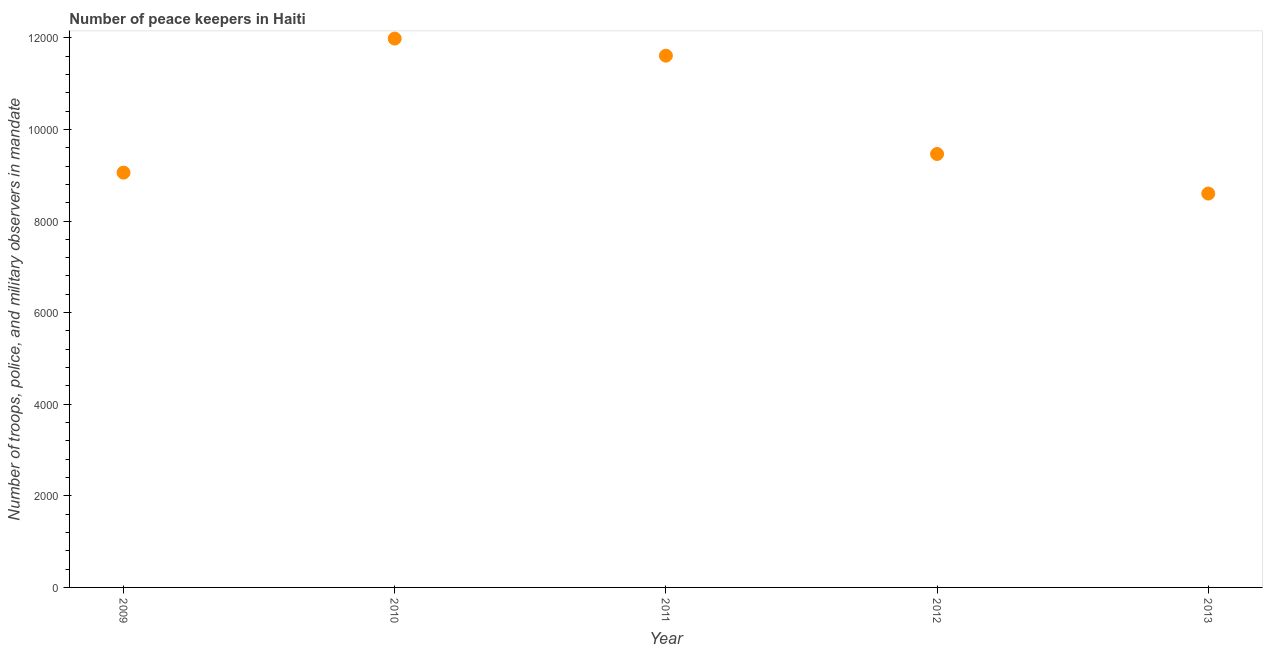What is the number of peace keepers in 2011?
Your answer should be very brief. 1.16e+04. Across all years, what is the maximum number of peace keepers?
Your answer should be very brief. 1.20e+04. Across all years, what is the minimum number of peace keepers?
Give a very brief answer. 8600. In which year was the number of peace keepers maximum?
Offer a terse response. 2010. What is the sum of the number of peace keepers?
Your answer should be very brief. 5.07e+04. What is the difference between the number of peace keepers in 2012 and 2013?
Keep it short and to the point. 864. What is the average number of peace keepers per year?
Provide a short and direct response. 1.01e+04. What is the median number of peace keepers?
Your answer should be compact. 9464. In how many years, is the number of peace keepers greater than 8000 ?
Provide a short and direct response. 5. What is the ratio of the number of peace keepers in 2010 to that in 2011?
Give a very brief answer. 1.03. What is the difference between the highest and the second highest number of peace keepers?
Your response must be concise. 373. What is the difference between the highest and the lowest number of peace keepers?
Make the answer very short. 3384. Does the number of peace keepers monotonically increase over the years?
Provide a succinct answer. No. How many years are there in the graph?
Make the answer very short. 5. What is the difference between two consecutive major ticks on the Y-axis?
Your answer should be very brief. 2000. Are the values on the major ticks of Y-axis written in scientific E-notation?
Make the answer very short. No. Does the graph contain any zero values?
Provide a succinct answer. No. What is the title of the graph?
Make the answer very short. Number of peace keepers in Haiti. What is the label or title of the Y-axis?
Ensure brevity in your answer.  Number of troops, police, and military observers in mandate. What is the Number of troops, police, and military observers in mandate in 2009?
Give a very brief answer. 9057. What is the Number of troops, police, and military observers in mandate in 2010?
Give a very brief answer. 1.20e+04. What is the Number of troops, police, and military observers in mandate in 2011?
Make the answer very short. 1.16e+04. What is the Number of troops, police, and military observers in mandate in 2012?
Offer a very short reply. 9464. What is the Number of troops, police, and military observers in mandate in 2013?
Your answer should be compact. 8600. What is the difference between the Number of troops, police, and military observers in mandate in 2009 and 2010?
Your answer should be very brief. -2927. What is the difference between the Number of troops, police, and military observers in mandate in 2009 and 2011?
Your response must be concise. -2554. What is the difference between the Number of troops, police, and military observers in mandate in 2009 and 2012?
Keep it short and to the point. -407. What is the difference between the Number of troops, police, and military observers in mandate in 2009 and 2013?
Provide a succinct answer. 457. What is the difference between the Number of troops, police, and military observers in mandate in 2010 and 2011?
Offer a very short reply. 373. What is the difference between the Number of troops, police, and military observers in mandate in 2010 and 2012?
Provide a succinct answer. 2520. What is the difference between the Number of troops, police, and military observers in mandate in 2010 and 2013?
Your answer should be very brief. 3384. What is the difference between the Number of troops, police, and military observers in mandate in 2011 and 2012?
Offer a very short reply. 2147. What is the difference between the Number of troops, police, and military observers in mandate in 2011 and 2013?
Your answer should be compact. 3011. What is the difference between the Number of troops, police, and military observers in mandate in 2012 and 2013?
Offer a very short reply. 864. What is the ratio of the Number of troops, police, and military observers in mandate in 2009 to that in 2010?
Ensure brevity in your answer.  0.76. What is the ratio of the Number of troops, police, and military observers in mandate in 2009 to that in 2011?
Provide a short and direct response. 0.78. What is the ratio of the Number of troops, police, and military observers in mandate in 2009 to that in 2012?
Give a very brief answer. 0.96. What is the ratio of the Number of troops, police, and military observers in mandate in 2009 to that in 2013?
Give a very brief answer. 1.05. What is the ratio of the Number of troops, police, and military observers in mandate in 2010 to that in 2011?
Ensure brevity in your answer.  1.03. What is the ratio of the Number of troops, police, and military observers in mandate in 2010 to that in 2012?
Your response must be concise. 1.27. What is the ratio of the Number of troops, police, and military observers in mandate in 2010 to that in 2013?
Your answer should be compact. 1.39. What is the ratio of the Number of troops, police, and military observers in mandate in 2011 to that in 2012?
Your response must be concise. 1.23. What is the ratio of the Number of troops, police, and military observers in mandate in 2011 to that in 2013?
Keep it short and to the point. 1.35. What is the ratio of the Number of troops, police, and military observers in mandate in 2012 to that in 2013?
Give a very brief answer. 1.1. 